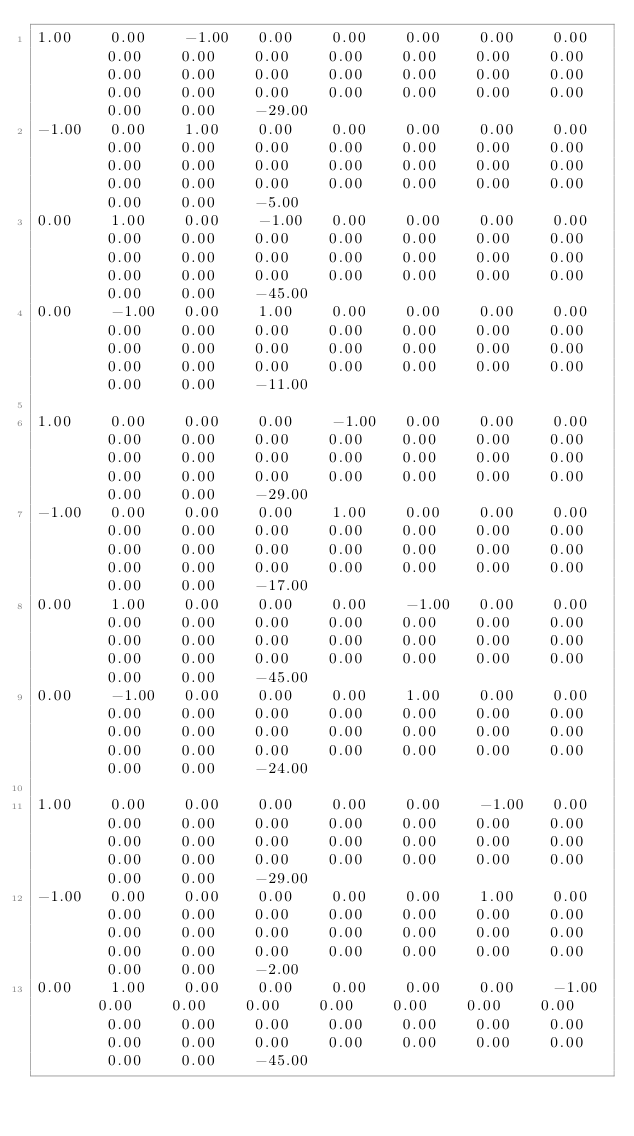<code> <loc_0><loc_0><loc_500><loc_500><_Matlab_>1.00	0.00	-1.00	0.00	0.00	0.00	0.00	0.00	0.00	0.00	0.00	0.00	0.00	0.00	0.00	0.00	0.00	0.00	0.00	0.00	0.00	0.00	0.00	0.00	0.00	0.00	0.00	0.00	0.00	0.00	0.00	-29.00
-1.00	0.00	1.00	0.00	0.00	0.00	0.00	0.00	0.00	0.00	0.00	0.00	0.00	0.00	0.00	0.00	0.00	0.00	0.00	0.00	0.00	0.00	0.00	0.00	0.00	0.00	0.00	0.00	0.00	0.00	0.00	-5.00
0.00	1.00	0.00	-1.00	0.00	0.00	0.00	0.00	0.00	0.00	0.00	0.00	0.00	0.00	0.00	0.00	0.00	0.00	0.00	0.00	0.00	0.00	0.00	0.00	0.00	0.00	0.00	0.00	0.00	0.00	0.00	-45.00
0.00	-1.00	0.00	1.00	0.00	0.00	0.00	0.00	0.00	0.00	0.00	0.00	0.00	0.00	0.00	0.00	0.00	0.00	0.00	0.00	0.00	0.00	0.00	0.00	0.00	0.00	0.00	0.00	0.00	0.00	0.00	-11.00

1.00	0.00	0.00	0.00	-1.00	0.00	0.00	0.00	0.00	0.00	0.00	0.00	0.00	0.00	0.00	0.00	0.00	0.00	0.00	0.00	0.00	0.00	0.00	0.00	0.00	0.00	0.00	0.00	0.00	0.00	0.00	-29.00
-1.00	0.00	0.00	0.00	1.00	0.00	0.00	0.00	0.00	0.00	0.00	0.00	0.00	0.00	0.00	0.00	0.00	0.00	0.00	0.00	0.00	0.00	0.00	0.00	0.00	0.00	0.00	0.00	0.00	0.00	0.00	-17.00
0.00	1.00	0.00	0.00	0.00	-1.00	0.00	0.00	0.00	0.00	0.00	0.00	0.00	0.00	0.00	0.00	0.00	0.00	0.00	0.00	0.00	0.00	0.00	0.00	0.00	0.00	0.00	0.00	0.00	0.00	0.00	-45.00
0.00	-1.00	0.00	0.00	0.00	1.00	0.00	0.00	0.00	0.00	0.00	0.00	0.00	0.00	0.00	0.00	0.00	0.00	0.00	0.00	0.00	0.00	0.00	0.00	0.00	0.00	0.00	0.00	0.00	0.00	0.00	-24.00

1.00	0.00	0.00	0.00	0.00	0.00	-1.00	0.00	0.00	0.00	0.00	0.00	0.00	0.00	0.00	0.00	0.00	0.00	0.00	0.00	0.00	0.00	0.00	0.00	0.00	0.00	0.00	0.00	0.00	0.00	0.00	-29.00
-1.00	0.00	0.00	0.00	0.00	0.00	1.00	0.00	0.00	0.00	0.00	0.00	0.00	0.00	0.00	0.00	0.00	0.00	0.00	0.00	0.00	0.00	0.00	0.00	0.00	0.00	0.00	0.00	0.00	0.00	0.00	-2.00
0.00	1.00	0.00	0.00	0.00	0.00	0.00	-1.00	0.00	0.00	0.00	0.00	0.00	0.00	0.00	0.00	0.00	0.00	0.00	0.00	0.00	0.00	0.00	0.00	0.00	0.00	0.00	0.00	0.00	0.00	0.00	-45.00</code> 